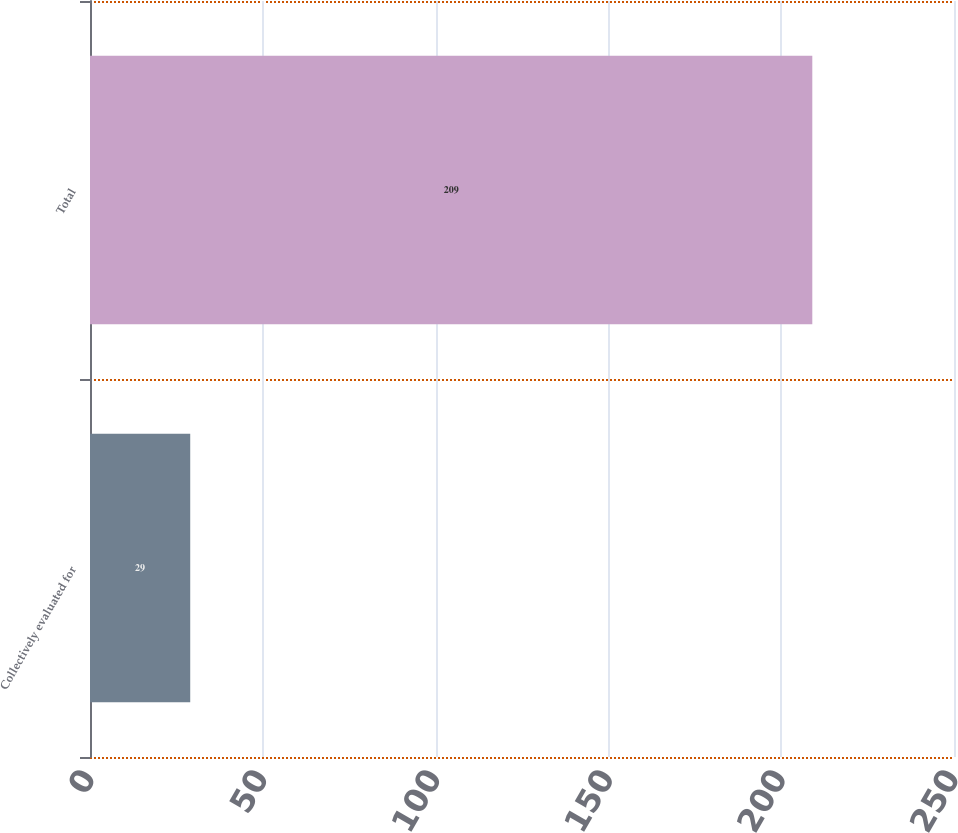<chart> <loc_0><loc_0><loc_500><loc_500><bar_chart><fcel>Collectively evaluated for<fcel>Total<nl><fcel>29<fcel>209<nl></chart> 